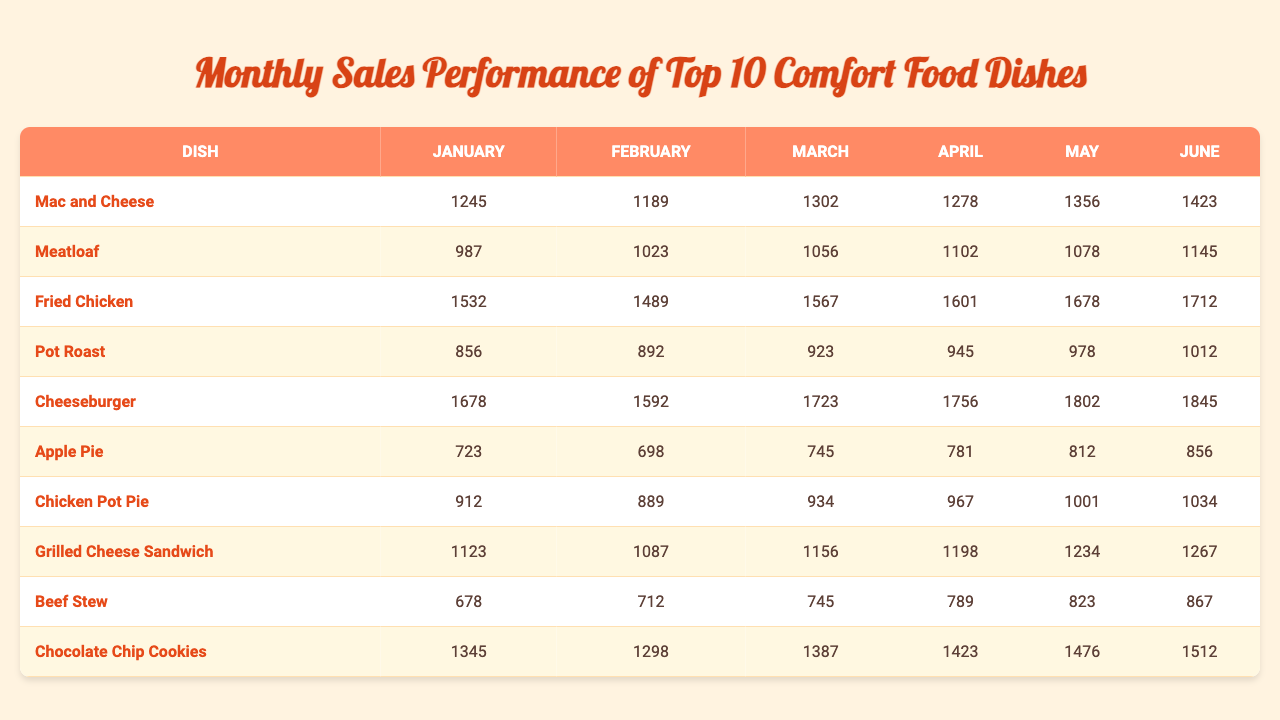What was the highest selling dish in May? By examining the data for May, we find that the highest selling dish is the Cheeseburger with 1802 units sold.
Answer: Cheeseburger Which dish showed the highest sales increase from January to February? The Fried Chicken had sales of 1532 in January and 1489 in February, showing a decrease; the Meatloaf increased from 987 in January to 1023 in February, with a sales increase of 36 units.
Answer: Meatloaf What were the total sales for Meatloaf from January to June? To find the total sales for Meatloaf, we add the monthly sales: 987 + 1023 + 1056 + 1102 + 1078 + 1145 = 6191.
Answer: 6191 Which month had the lowest sales for Grilled Cheese Sandwich? The month of February had the lowest sales for Grilled Cheese Sandwich, with sales of 1087.
Answer: February Is the average sales for Apple Pie higher than that of Beef Stew? First, calculate the average for Apple Pie: (723 + 698 + 745 + 781 + 812 + 856) / 6 = 752.5; for Beef Stew: (678 + 712 + 745 + 789 + 823 + 867) / 6 = 745. So, Apple Pie's average is higher than that of Beef Stew.
Answer: Yes Which dish had a consistent increase in sales from January to June? The Fried Chicken shows a consistent increase in sales from 1532 in January to 1712 in June, with sales rising each month without any dips.
Answer: Fried Chicken What is the median sales number for Chocolate Chip Cookies over the six months? To find the median, we order the monthly sales numbers: 1298, 1345, 1387, 1423, 1476, and 1512. The median is the average of the two middle values: (1387 + 1423) / 2 = 1405.
Answer: 1405 In which month did Mac and Cheese sell the most units? The sales for Mac and Cheese peaked in May when it sold 1356 units.
Answer: May How many more units of Cheeseburger were sold in March than in January? The Cheeseburger sold 1723 in March and 1678 in January. To find the difference, subtract: 1723 - 1678 = 45.
Answer: 45 Which dish had the lowest sales overall in the six-month period? The dish with the lowest total sales is Beef Stew, totaling 3904 units (678 + 712 + 745 + 789 + 823 + 867).
Answer: Beef Stew 